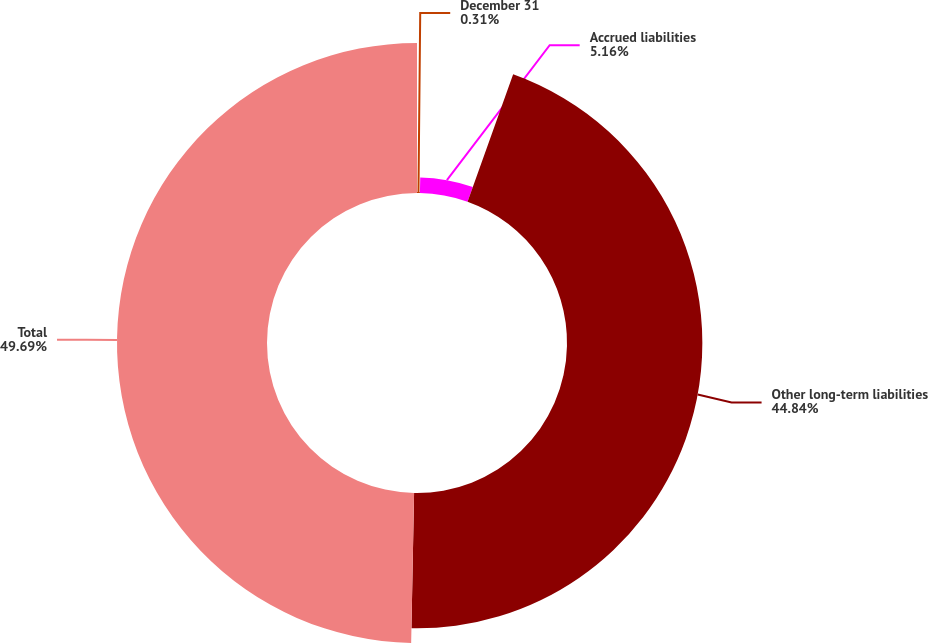<chart> <loc_0><loc_0><loc_500><loc_500><pie_chart><fcel>December 31<fcel>Accrued liabilities<fcel>Other long-term liabilities<fcel>Total<nl><fcel>0.31%<fcel>5.16%<fcel>44.84%<fcel>49.69%<nl></chart> 